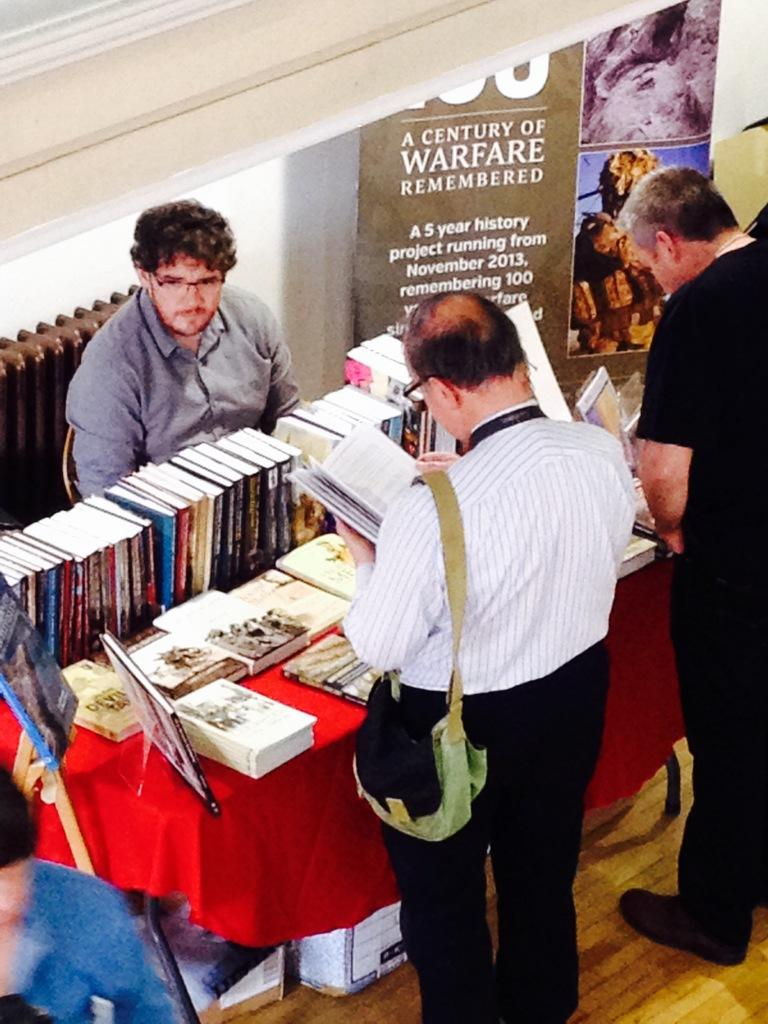<image>
Describe the image concisely. A man wearing glasses is sitting at the book table next to the sign about warfare as people read through the books. 